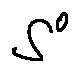<formula> <loc_0><loc_0><loc_500><loc_500>S ^ { 0 }</formula> 